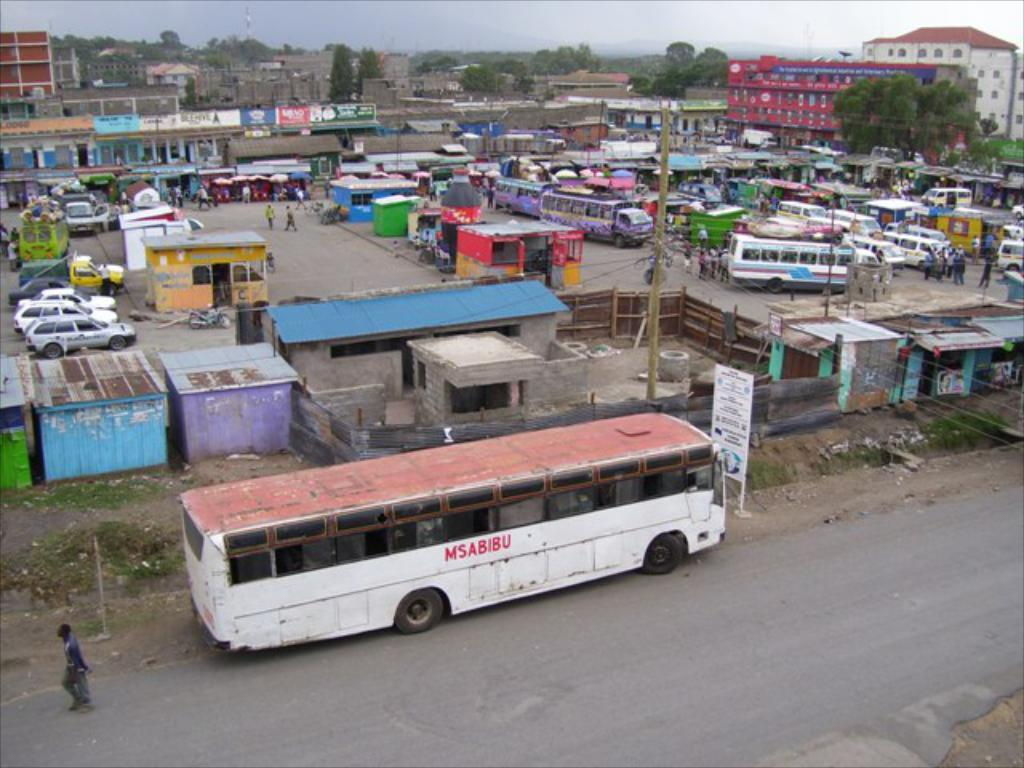What types of objects are present in the image? There are vehicles, small rooms, and persons on the ground in the image. What can be seen in the background of the image? There are buildings, trees, poles, hoardings, and the sky visible in the background of the image. Can you see a nest in the image? There is no nest present in the image. What type of need is being fulfilled by the goldfish in the image? There are no goldfish present in the image. 